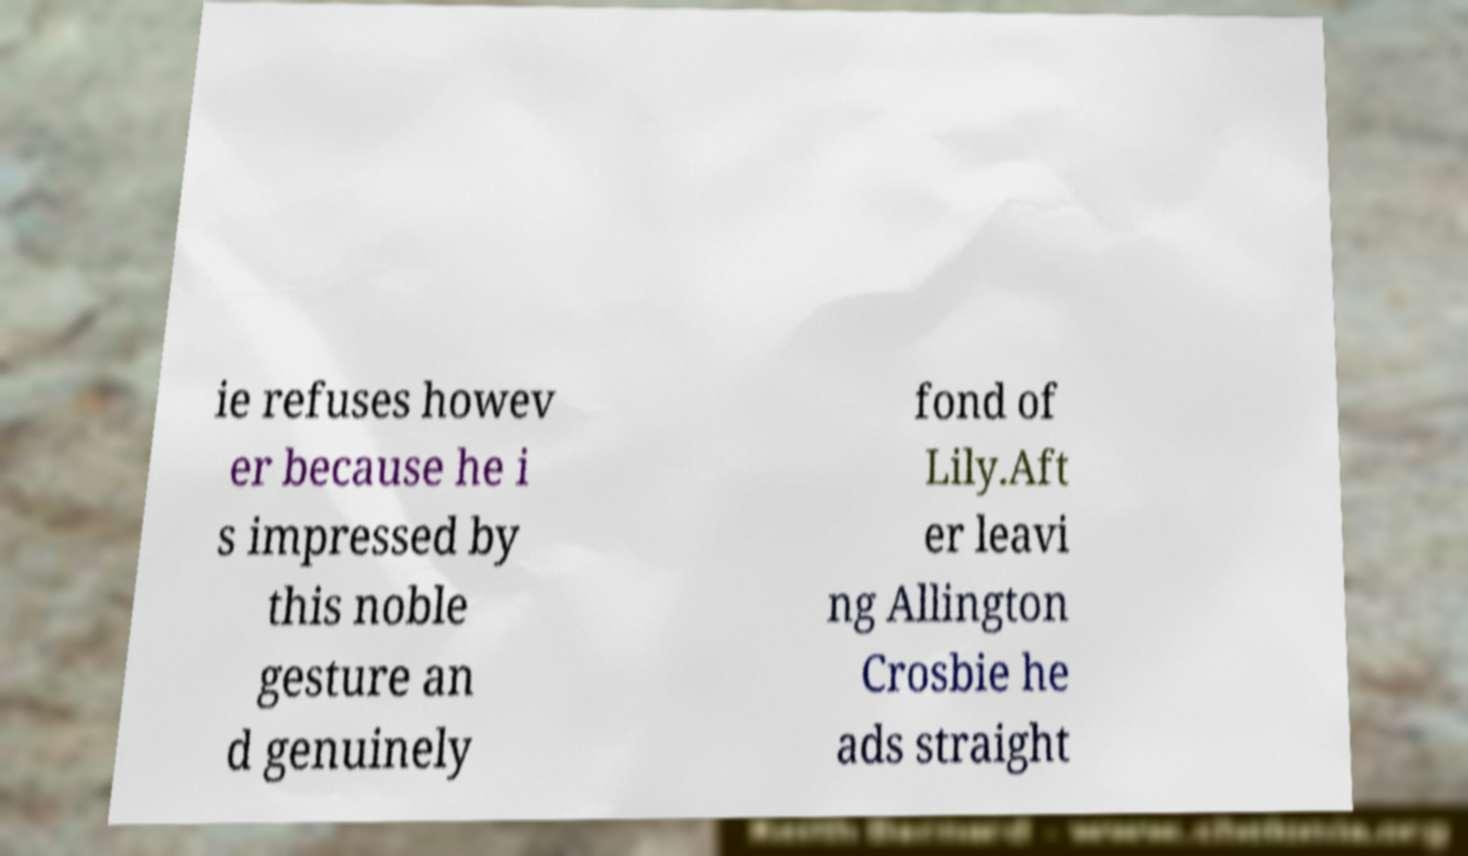Please read and relay the text visible in this image. What does it say? ie refuses howev er because he i s impressed by this noble gesture an d genuinely fond of Lily.Aft er leavi ng Allington Crosbie he ads straight 